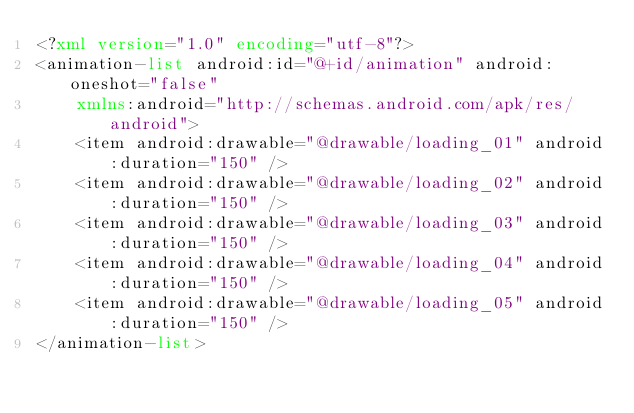<code> <loc_0><loc_0><loc_500><loc_500><_XML_><?xml version="1.0" encoding="utf-8"?>
<animation-list android:id="@+id/animation" android:oneshot="false"
    xmlns:android="http://schemas.android.com/apk/res/android">
    <item android:drawable="@drawable/loading_01" android:duration="150" />
    <item android:drawable="@drawable/loading_02" android:duration="150" />
    <item android:drawable="@drawable/loading_03" android:duration="150" />
    <item android:drawable="@drawable/loading_04" android:duration="150" />
    <item android:drawable="@drawable/loading_05" android:duration="150" />
</animation-list></code> 